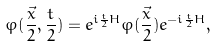Convert formula to latex. <formula><loc_0><loc_0><loc_500><loc_500>\varphi ( \frac { \vec { x } } { 2 } , \frac { t } { 2 } ) = e ^ { i \frac { t } { 2 } H } \varphi ( \frac { \vec { x } } { 2 } ) e ^ { - i \frac { t } { 2 } H } ,</formula> 